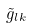Convert formula to latex. <formula><loc_0><loc_0><loc_500><loc_500>\tilde { g } _ { l k }</formula> 